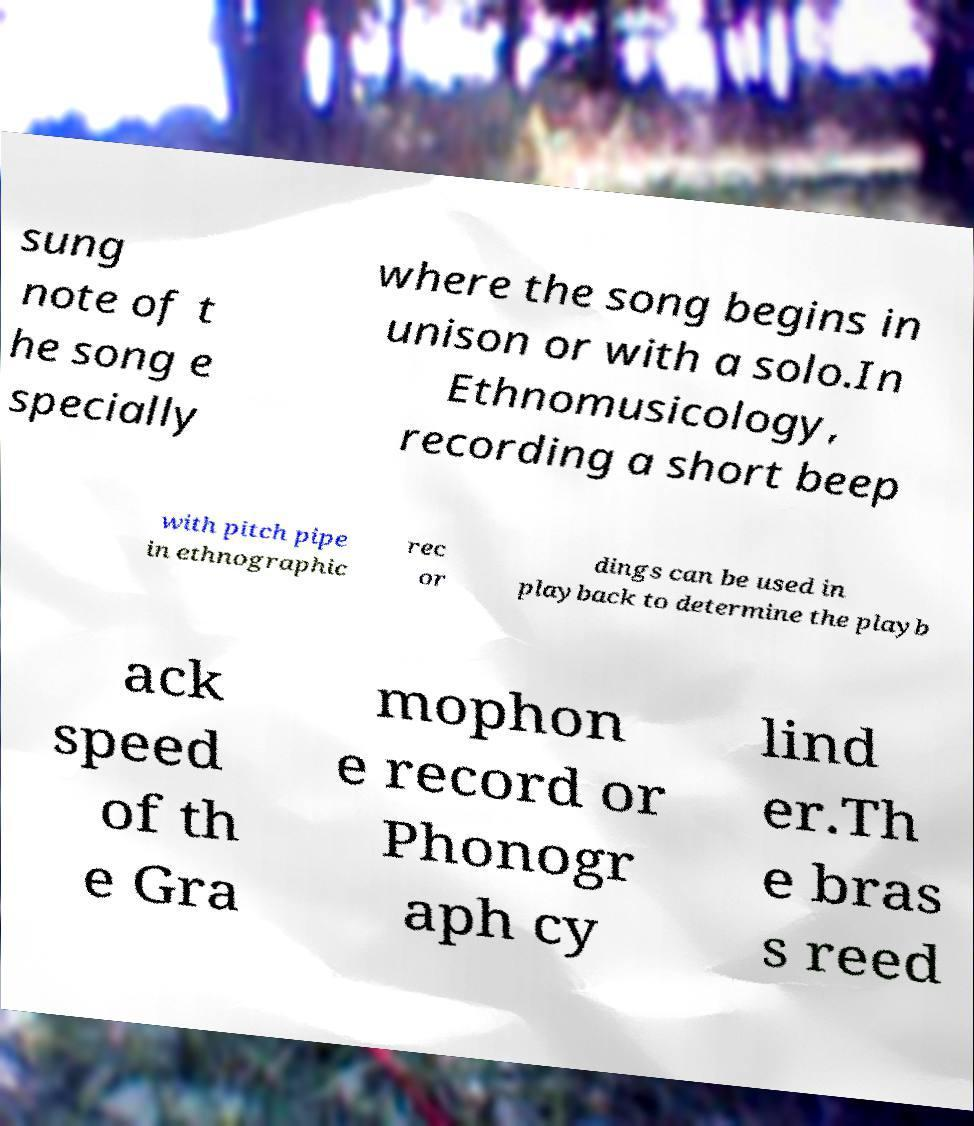Can you read and provide the text displayed in the image?This photo seems to have some interesting text. Can you extract and type it out for me? sung note of t he song e specially where the song begins in unison or with a solo.In Ethnomusicology, recording a short beep with pitch pipe in ethnographic rec or dings can be used in playback to determine the playb ack speed of th e Gra mophon e record or Phonogr aph cy lind er.Th e bras s reed 